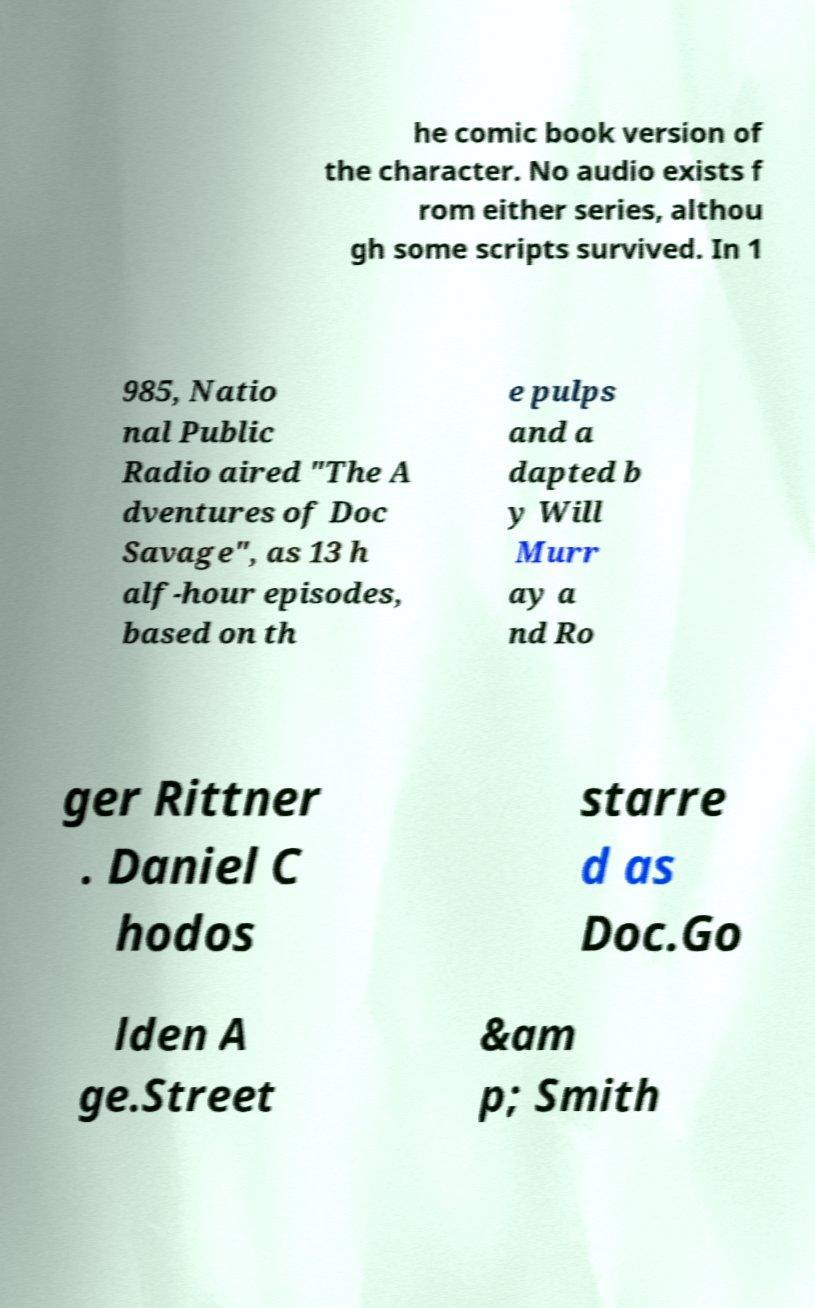Please read and relay the text visible in this image. What does it say? he comic book version of the character. No audio exists f rom either series, althou gh some scripts survived. In 1 985, Natio nal Public Radio aired "The A dventures of Doc Savage", as 13 h alf-hour episodes, based on th e pulps and a dapted b y Will Murr ay a nd Ro ger Rittner . Daniel C hodos starre d as Doc.Go lden A ge.Street &am p; Smith 